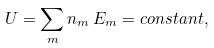<formula> <loc_0><loc_0><loc_500><loc_500>U = \sum _ { m } n _ { m } \, E _ { m } = c o n s t a n t ,</formula> 